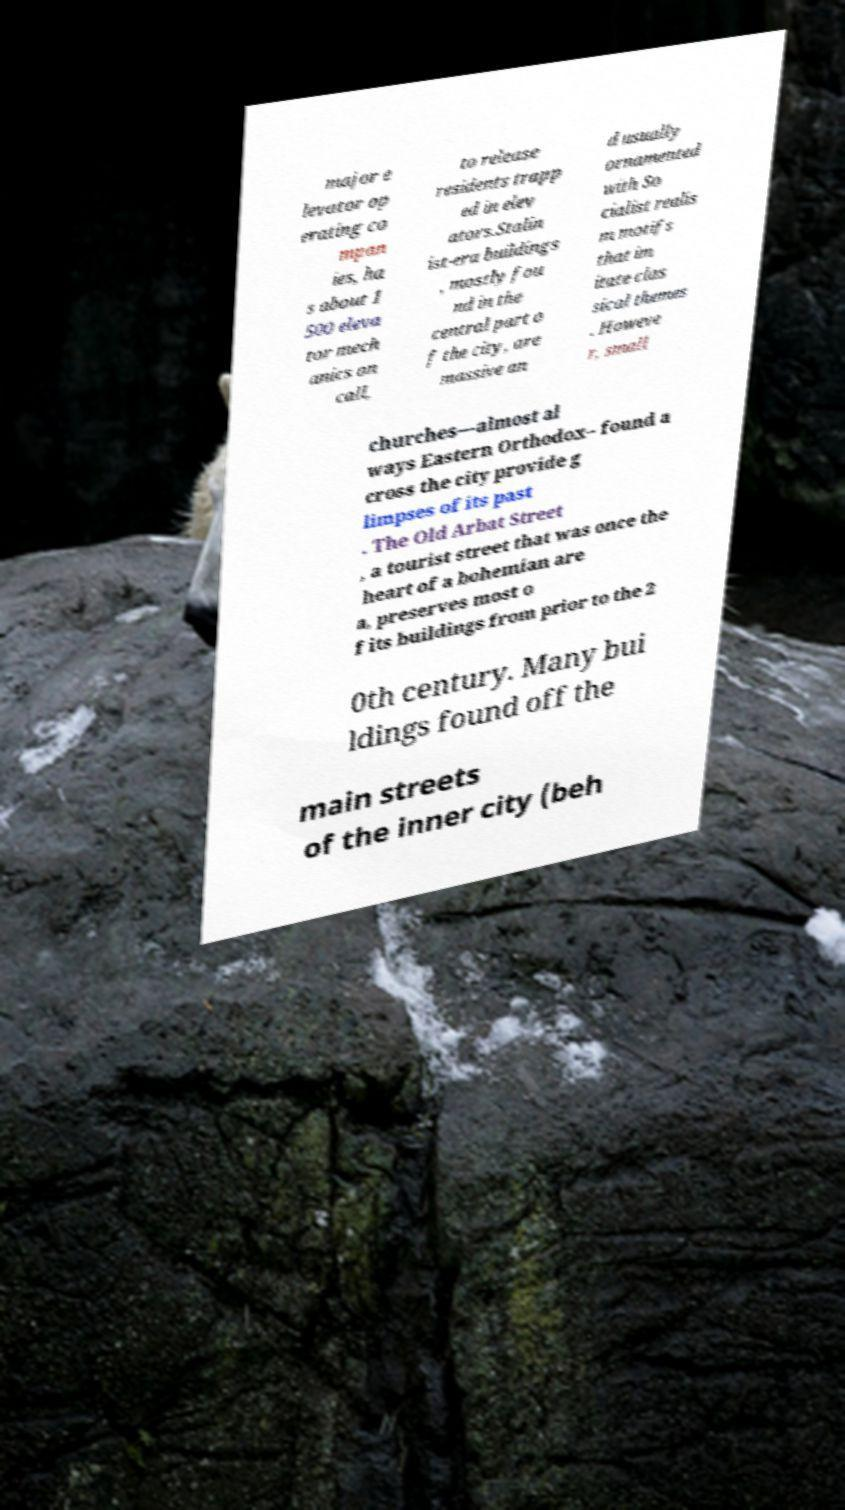Please read and relay the text visible in this image. What does it say? major e levator op erating co mpan ies, ha s about 1 500 eleva tor mech anics on call, to release residents trapp ed in elev ators.Stalin ist-era buildings , mostly fou nd in the central part o f the city, are massive an d usually ornamented with So cialist realis m motifs that im itate clas sical themes . Howeve r, small churches—almost al ways Eastern Orthodox– found a cross the city provide g limpses of its past . The Old Arbat Street , a tourist street that was once the heart of a bohemian are a, preserves most o f its buildings from prior to the 2 0th century. Many bui ldings found off the main streets of the inner city (beh 